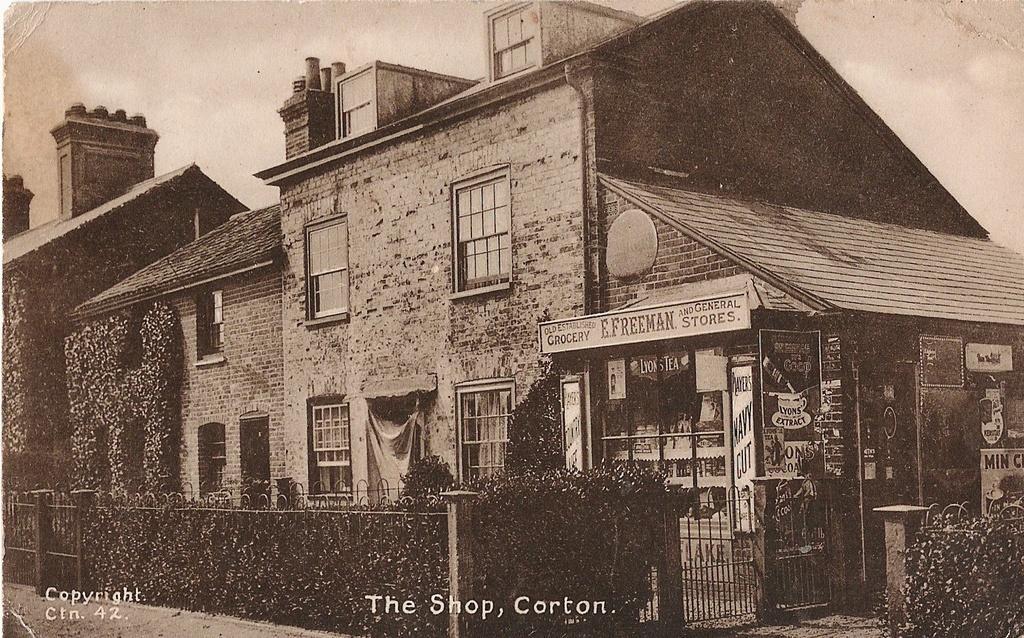In one or two sentences, can you explain what this image depicts? This is an edited picture. In this image there are buildings and there are plants and there are boards on the buildings and there is text on the boards. In the foreground there is a railing. At the top there is sky. At the bottom there is text. At the bottom left there is text. 